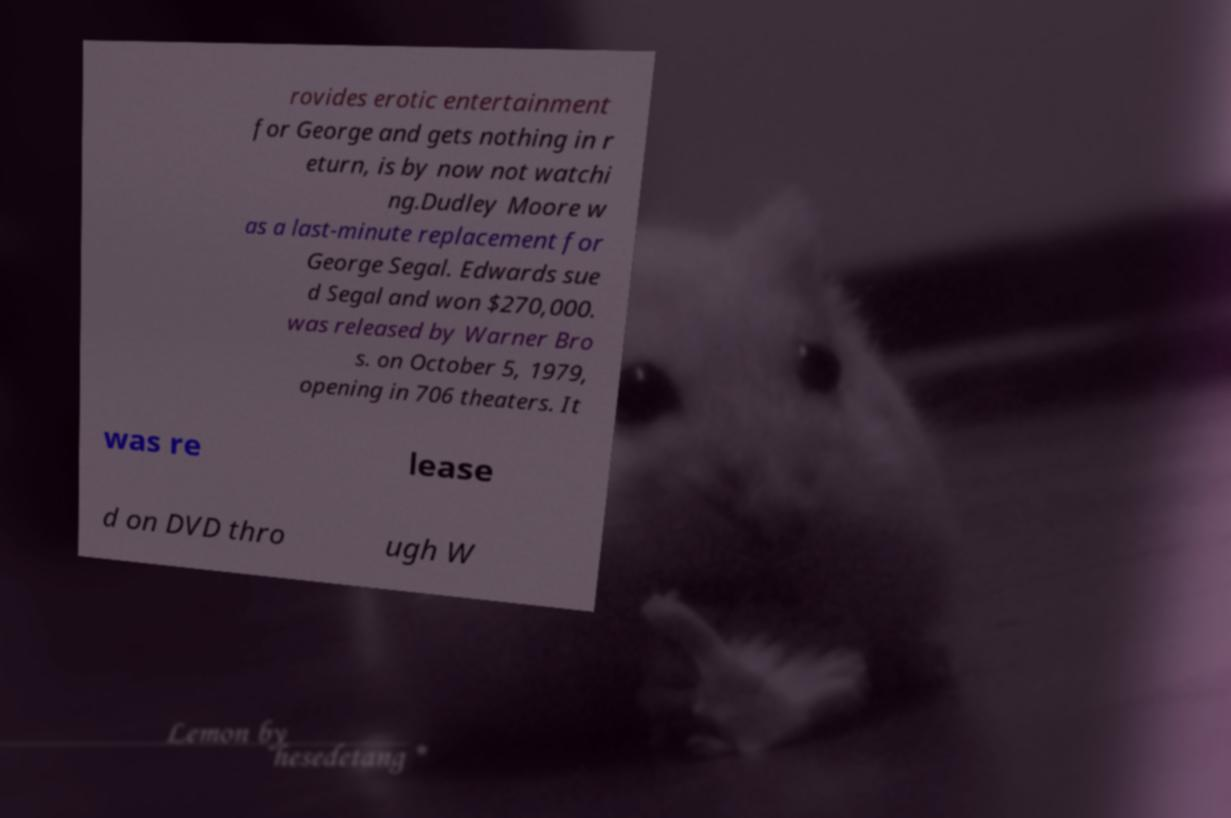What messages or text are displayed in this image? I need them in a readable, typed format. rovides erotic entertainment for George and gets nothing in r eturn, is by now not watchi ng.Dudley Moore w as a last-minute replacement for George Segal. Edwards sue d Segal and won $270,000. was released by Warner Bro s. on October 5, 1979, opening in 706 theaters. It was re lease d on DVD thro ugh W 